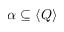Convert formula to latex. <formula><loc_0><loc_0><loc_500><loc_500>\alpha \subseteq \langle Q \rangle</formula> 